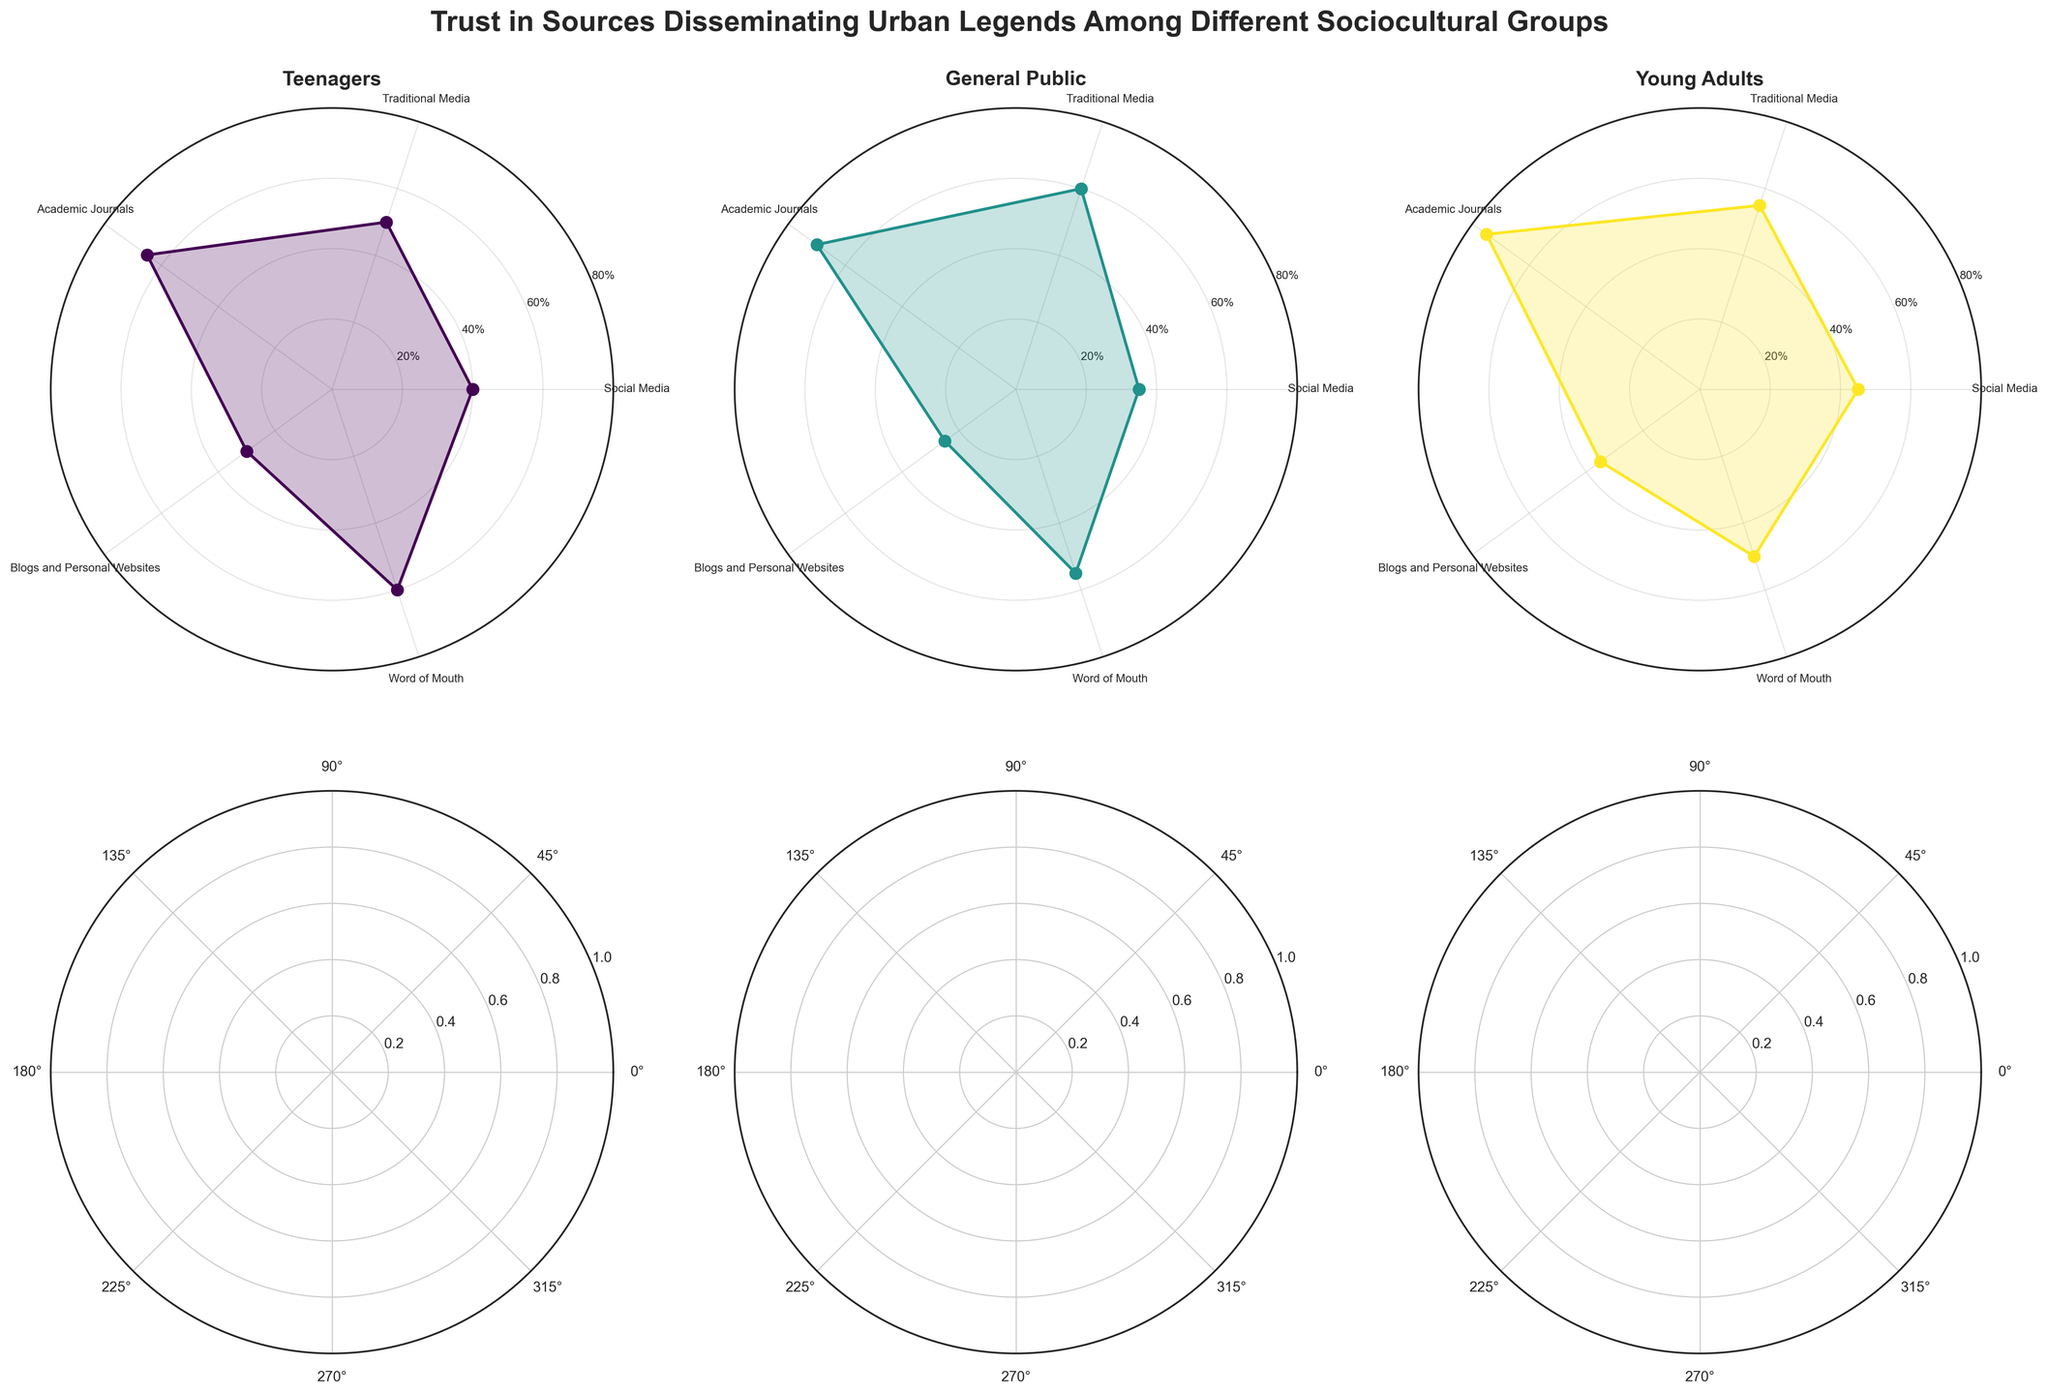How many sociocultural groups are presented? There are six subplots, each with a title representing a different sociocultural group: Teenagers, General Public, Young Adults.
Answer: 3 For which group does 'Academic Journals' have the highest trust level? By looking at the sections of the polar charts, 'Academic Journals' has the highest trust level for Young Adults with a value of 75.
Answer: Young Adults What is the average trust level for 'Traditional Media' among all groups? Traditional Media has the trust levels: General Public (60), Teenagers (50), and Young Adults (55). The average is (60 + 50 + 55) / 3 = 55.
Answer: 55 Which group shows the least trust in 'Social Media'? By comparing the trust levels for 'Social Media' across all groups, Europe (General Public) shows the least trust with a value of 35.
Answer: General Public (Europe) What source has the lowest trust level across all the groups? The least trusted source across all groups and regions is 'Blogs and Personal Websites' with values of 30 (Teenagers, North America), 25 (General Public, Europe), and 35 (Young Adults, Africa). The lowest value among these is 25.
Answer: Blogs and Personal Websites (General Public, Europe) Compare the trust levels for 'Word of Mouth' between 'Teenagers' and 'Young Adults'. Which group has a higher trust level? 'Teenagers' have a trust level of 60, while 'Young Adults' have a trust level of 50. Thus, Teenagers have a higher trust level.
Answer: Teenagers Which source is most trusted by the General Public in North America? The polar chart for the General Public in North America shows the highest value for 'Academic Journals' at 70.
Answer: Academic Journals What is the difference in trust levels for 'Blogs and Personal Websites' between Teenagers in North America and the General Public in Europe? Teenagers in North America have a trust level of 30, while the General Public in Europe has a trust level of 25. The difference is 30 - 25 = 5.
Answer: 5 Which group trusts 'Social Media' the most? Looking at the polar charts, Young Adults in Asia have the highest trust level for 'Social Media' with a value of 45.
Answer: Young Adults (Asia) What is the overall trend of trust levels in 'Traditional Media' across regions? 'Traditional Media' has values of 60, 50, and 55, showing relatively high and consistent trust levels across different regions. This indicates that 'Traditional Media' is generally trusted more consistently across different groups.
Answer: Consistently high 